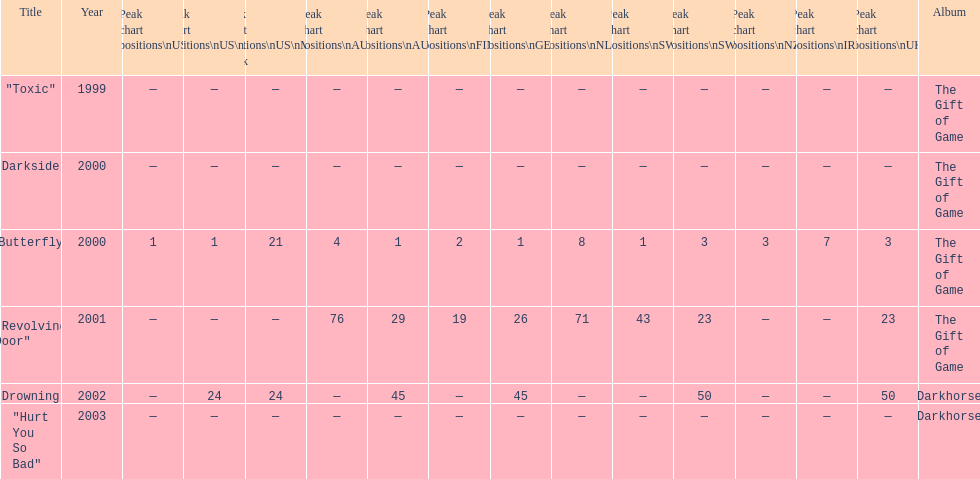When did "drowning" peak at 24 in the us alternate group? 2002. 